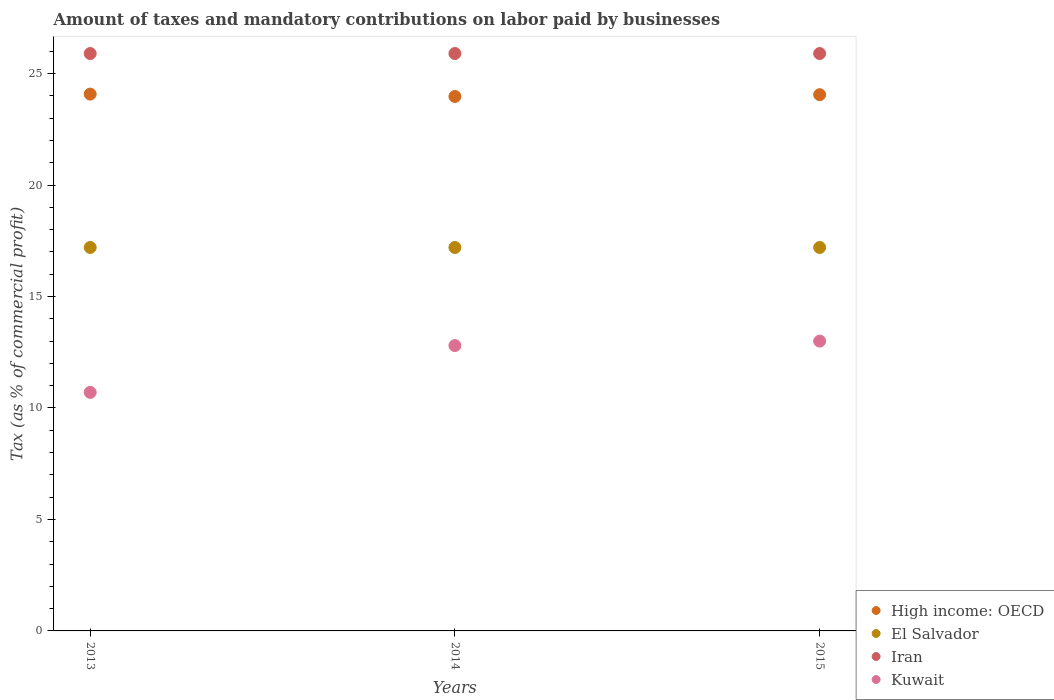How many different coloured dotlines are there?
Give a very brief answer. 4. What is the percentage of taxes paid by businesses in High income: OECD in 2015?
Your response must be concise. 24.05. Across all years, what is the maximum percentage of taxes paid by businesses in El Salvador?
Your answer should be compact. 17.2. Across all years, what is the minimum percentage of taxes paid by businesses in Iran?
Offer a very short reply. 25.9. In which year was the percentage of taxes paid by businesses in El Salvador maximum?
Make the answer very short. 2013. In which year was the percentage of taxes paid by businesses in El Salvador minimum?
Provide a short and direct response. 2013. What is the total percentage of taxes paid by businesses in High income: OECD in the graph?
Your answer should be compact. 72.11. What is the difference between the percentage of taxes paid by businesses in Kuwait in 2014 and that in 2015?
Offer a very short reply. -0.2. What is the difference between the percentage of taxes paid by businesses in El Salvador in 2015 and the percentage of taxes paid by businesses in Iran in 2014?
Give a very brief answer. -8.7. What is the average percentage of taxes paid by businesses in Iran per year?
Ensure brevity in your answer.  25.9. In the year 2015, what is the difference between the percentage of taxes paid by businesses in El Salvador and percentage of taxes paid by businesses in Kuwait?
Offer a terse response. 4.2. What is the ratio of the percentage of taxes paid by businesses in Kuwait in 2013 to that in 2015?
Your response must be concise. 0.82. Is the percentage of taxes paid by businesses in High income: OECD in 2014 less than that in 2015?
Your answer should be compact. Yes. Is the difference between the percentage of taxes paid by businesses in El Salvador in 2013 and 2015 greater than the difference between the percentage of taxes paid by businesses in Kuwait in 2013 and 2015?
Provide a succinct answer. Yes. What is the difference between the highest and the second highest percentage of taxes paid by businesses in Iran?
Keep it short and to the point. 0. What is the difference between the highest and the lowest percentage of taxes paid by businesses in High income: OECD?
Your response must be concise. 0.11. In how many years, is the percentage of taxes paid by businesses in El Salvador greater than the average percentage of taxes paid by businesses in El Salvador taken over all years?
Your answer should be very brief. 0. Is the percentage of taxes paid by businesses in High income: OECD strictly greater than the percentage of taxes paid by businesses in Iran over the years?
Make the answer very short. No. Is the percentage of taxes paid by businesses in Iran strictly less than the percentage of taxes paid by businesses in Kuwait over the years?
Provide a short and direct response. No. Does the graph contain any zero values?
Keep it short and to the point. No. How are the legend labels stacked?
Your response must be concise. Vertical. What is the title of the graph?
Your answer should be very brief. Amount of taxes and mandatory contributions on labor paid by businesses. Does "Egypt, Arab Rep." appear as one of the legend labels in the graph?
Provide a succinct answer. No. What is the label or title of the X-axis?
Give a very brief answer. Years. What is the label or title of the Y-axis?
Offer a terse response. Tax (as % of commercial profit). What is the Tax (as % of commercial profit) of High income: OECD in 2013?
Keep it short and to the point. 24.08. What is the Tax (as % of commercial profit) in Iran in 2013?
Provide a succinct answer. 25.9. What is the Tax (as % of commercial profit) in Kuwait in 2013?
Your response must be concise. 10.7. What is the Tax (as % of commercial profit) of High income: OECD in 2014?
Your answer should be very brief. 23.97. What is the Tax (as % of commercial profit) of Iran in 2014?
Offer a very short reply. 25.9. What is the Tax (as % of commercial profit) in High income: OECD in 2015?
Offer a very short reply. 24.05. What is the Tax (as % of commercial profit) in Iran in 2015?
Your answer should be compact. 25.9. What is the Tax (as % of commercial profit) in Kuwait in 2015?
Keep it short and to the point. 13. Across all years, what is the maximum Tax (as % of commercial profit) of High income: OECD?
Make the answer very short. 24.08. Across all years, what is the maximum Tax (as % of commercial profit) in Iran?
Your response must be concise. 25.9. Across all years, what is the maximum Tax (as % of commercial profit) of Kuwait?
Offer a terse response. 13. Across all years, what is the minimum Tax (as % of commercial profit) of High income: OECD?
Your response must be concise. 23.97. Across all years, what is the minimum Tax (as % of commercial profit) of Iran?
Provide a short and direct response. 25.9. Across all years, what is the minimum Tax (as % of commercial profit) of Kuwait?
Your answer should be compact. 10.7. What is the total Tax (as % of commercial profit) of High income: OECD in the graph?
Offer a very short reply. 72.11. What is the total Tax (as % of commercial profit) in El Salvador in the graph?
Provide a short and direct response. 51.6. What is the total Tax (as % of commercial profit) of Iran in the graph?
Offer a terse response. 77.7. What is the total Tax (as % of commercial profit) in Kuwait in the graph?
Provide a short and direct response. 36.5. What is the difference between the Tax (as % of commercial profit) in High income: OECD in 2013 and that in 2014?
Your answer should be very brief. 0.11. What is the difference between the Tax (as % of commercial profit) in Iran in 2013 and that in 2014?
Make the answer very short. 0. What is the difference between the Tax (as % of commercial profit) of Kuwait in 2013 and that in 2014?
Your answer should be very brief. -2.1. What is the difference between the Tax (as % of commercial profit) in High income: OECD in 2013 and that in 2015?
Offer a terse response. 0.03. What is the difference between the Tax (as % of commercial profit) in El Salvador in 2013 and that in 2015?
Your answer should be compact. 0. What is the difference between the Tax (as % of commercial profit) in Iran in 2013 and that in 2015?
Offer a very short reply. 0. What is the difference between the Tax (as % of commercial profit) of High income: OECD in 2014 and that in 2015?
Your response must be concise. -0.08. What is the difference between the Tax (as % of commercial profit) in Iran in 2014 and that in 2015?
Make the answer very short. 0. What is the difference between the Tax (as % of commercial profit) in High income: OECD in 2013 and the Tax (as % of commercial profit) in El Salvador in 2014?
Provide a short and direct response. 6.88. What is the difference between the Tax (as % of commercial profit) in High income: OECD in 2013 and the Tax (as % of commercial profit) in Iran in 2014?
Give a very brief answer. -1.82. What is the difference between the Tax (as % of commercial profit) of High income: OECD in 2013 and the Tax (as % of commercial profit) of Kuwait in 2014?
Keep it short and to the point. 11.28. What is the difference between the Tax (as % of commercial profit) of El Salvador in 2013 and the Tax (as % of commercial profit) of Kuwait in 2014?
Your response must be concise. 4.4. What is the difference between the Tax (as % of commercial profit) in Iran in 2013 and the Tax (as % of commercial profit) in Kuwait in 2014?
Keep it short and to the point. 13.1. What is the difference between the Tax (as % of commercial profit) of High income: OECD in 2013 and the Tax (as % of commercial profit) of El Salvador in 2015?
Offer a terse response. 6.88. What is the difference between the Tax (as % of commercial profit) in High income: OECD in 2013 and the Tax (as % of commercial profit) in Iran in 2015?
Your answer should be compact. -1.82. What is the difference between the Tax (as % of commercial profit) of High income: OECD in 2013 and the Tax (as % of commercial profit) of Kuwait in 2015?
Provide a short and direct response. 11.08. What is the difference between the Tax (as % of commercial profit) of El Salvador in 2013 and the Tax (as % of commercial profit) of Iran in 2015?
Ensure brevity in your answer.  -8.7. What is the difference between the Tax (as % of commercial profit) of El Salvador in 2013 and the Tax (as % of commercial profit) of Kuwait in 2015?
Your answer should be very brief. 4.2. What is the difference between the Tax (as % of commercial profit) in High income: OECD in 2014 and the Tax (as % of commercial profit) in El Salvador in 2015?
Keep it short and to the point. 6.77. What is the difference between the Tax (as % of commercial profit) of High income: OECD in 2014 and the Tax (as % of commercial profit) of Iran in 2015?
Your answer should be compact. -1.93. What is the difference between the Tax (as % of commercial profit) in High income: OECD in 2014 and the Tax (as % of commercial profit) in Kuwait in 2015?
Keep it short and to the point. 10.97. What is the difference between the Tax (as % of commercial profit) of Iran in 2014 and the Tax (as % of commercial profit) of Kuwait in 2015?
Provide a succinct answer. 12.9. What is the average Tax (as % of commercial profit) of High income: OECD per year?
Give a very brief answer. 24.04. What is the average Tax (as % of commercial profit) in Iran per year?
Your answer should be very brief. 25.9. What is the average Tax (as % of commercial profit) of Kuwait per year?
Provide a short and direct response. 12.17. In the year 2013, what is the difference between the Tax (as % of commercial profit) in High income: OECD and Tax (as % of commercial profit) in El Salvador?
Offer a terse response. 6.88. In the year 2013, what is the difference between the Tax (as % of commercial profit) of High income: OECD and Tax (as % of commercial profit) of Iran?
Your answer should be very brief. -1.82. In the year 2013, what is the difference between the Tax (as % of commercial profit) in High income: OECD and Tax (as % of commercial profit) in Kuwait?
Make the answer very short. 13.38. In the year 2013, what is the difference between the Tax (as % of commercial profit) in El Salvador and Tax (as % of commercial profit) in Iran?
Make the answer very short. -8.7. In the year 2014, what is the difference between the Tax (as % of commercial profit) of High income: OECD and Tax (as % of commercial profit) of El Salvador?
Give a very brief answer. 6.77. In the year 2014, what is the difference between the Tax (as % of commercial profit) of High income: OECD and Tax (as % of commercial profit) of Iran?
Keep it short and to the point. -1.93. In the year 2014, what is the difference between the Tax (as % of commercial profit) in High income: OECD and Tax (as % of commercial profit) in Kuwait?
Your response must be concise. 11.17. In the year 2014, what is the difference between the Tax (as % of commercial profit) in Iran and Tax (as % of commercial profit) in Kuwait?
Ensure brevity in your answer.  13.1. In the year 2015, what is the difference between the Tax (as % of commercial profit) in High income: OECD and Tax (as % of commercial profit) in El Salvador?
Offer a terse response. 6.85. In the year 2015, what is the difference between the Tax (as % of commercial profit) in High income: OECD and Tax (as % of commercial profit) in Iran?
Your response must be concise. -1.85. In the year 2015, what is the difference between the Tax (as % of commercial profit) in High income: OECD and Tax (as % of commercial profit) in Kuwait?
Provide a succinct answer. 11.05. In the year 2015, what is the difference between the Tax (as % of commercial profit) in El Salvador and Tax (as % of commercial profit) in Iran?
Give a very brief answer. -8.7. In the year 2015, what is the difference between the Tax (as % of commercial profit) of El Salvador and Tax (as % of commercial profit) of Kuwait?
Provide a short and direct response. 4.2. What is the ratio of the Tax (as % of commercial profit) in High income: OECD in 2013 to that in 2014?
Offer a very short reply. 1. What is the ratio of the Tax (as % of commercial profit) in El Salvador in 2013 to that in 2014?
Give a very brief answer. 1. What is the ratio of the Tax (as % of commercial profit) in Kuwait in 2013 to that in 2014?
Your answer should be very brief. 0.84. What is the ratio of the Tax (as % of commercial profit) in High income: OECD in 2013 to that in 2015?
Provide a succinct answer. 1. What is the ratio of the Tax (as % of commercial profit) in Kuwait in 2013 to that in 2015?
Make the answer very short. 0.82. What is the ratio of the Tax (as % of commercial profit) of Iran in 2014 to that in 2015?
Your answer should be compact. 1. What is the ratio of the Tax (as % of commercial profit) in Kuwait in 2014 to that in 2015?
Make the answer very short. 0.98. What is the difference between the highest and the second highest Tax (as % of commercial profit) of High income: OECD?
Keep it short and to the point. 0.03. What is the difference between the highest and the second highest Tax (as % of commercial profit) of El Salvador?
Ensure brevity in your answer.  0. What is the difference between the highest and the second highest Tax (as % of commercial profit) in Iran?
Your response must be concise. 0. What is the difference between the highest and the lowest Tax (as % of commercial profit) in High income: OECD?
Your answer should be compact. 0.11. What is the difference between the highest and the lowest Tax (as % of commercial profit) of Iran?
Offer a terse response. 0. What is the difference between the highest and the lowest Tax (as % of commercial profit) in Kuwait?
Provide a short and direct response. 2.3. 